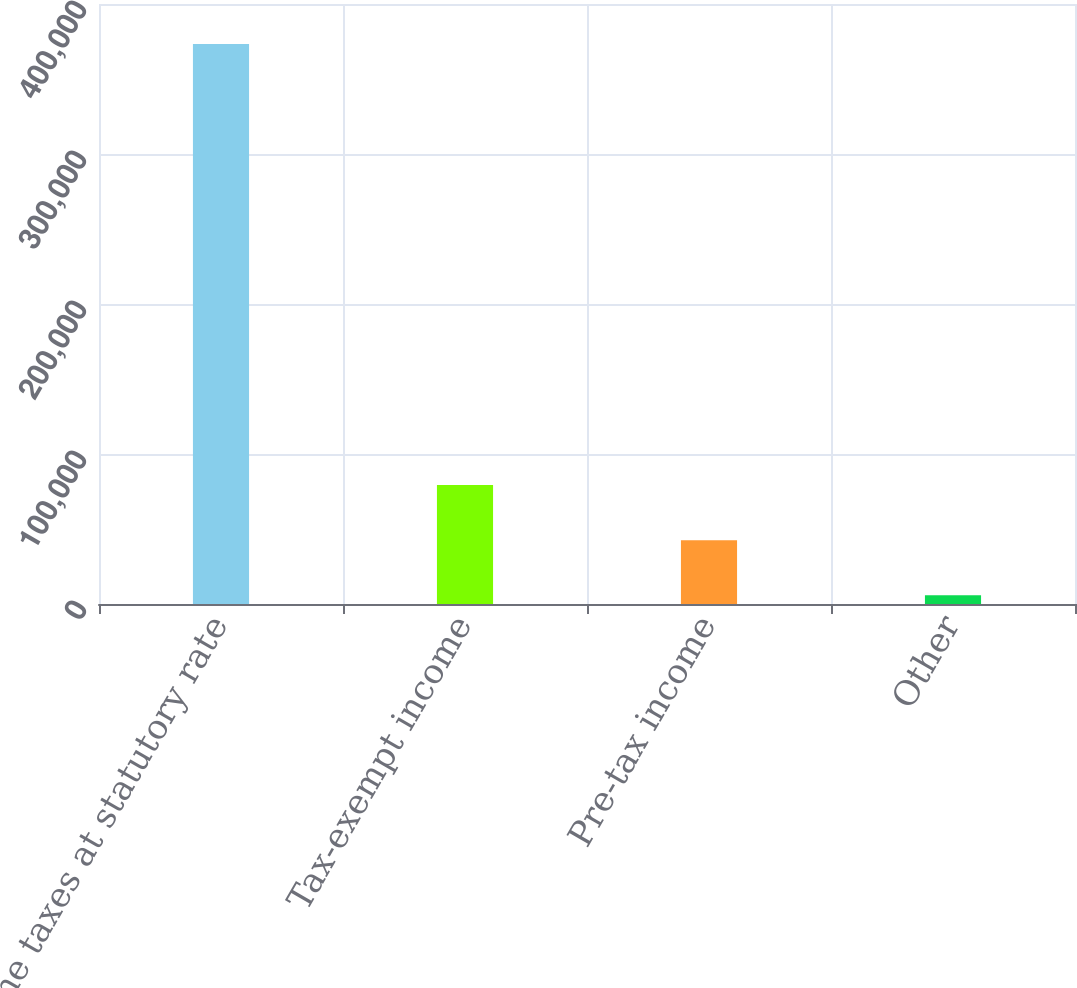Convert chart to OTSL. <chart><loc_0><loc_0><loc_500><loc_500><bar_chart><fcel>Income taxes at statutory rate<fcel>Tax-exempt income<fcel>Pre-tax income<fcel>Other<nl><fcel>373283<fcel>79321.4<fcel>42576.2<fcel>5831<nl></chart> 